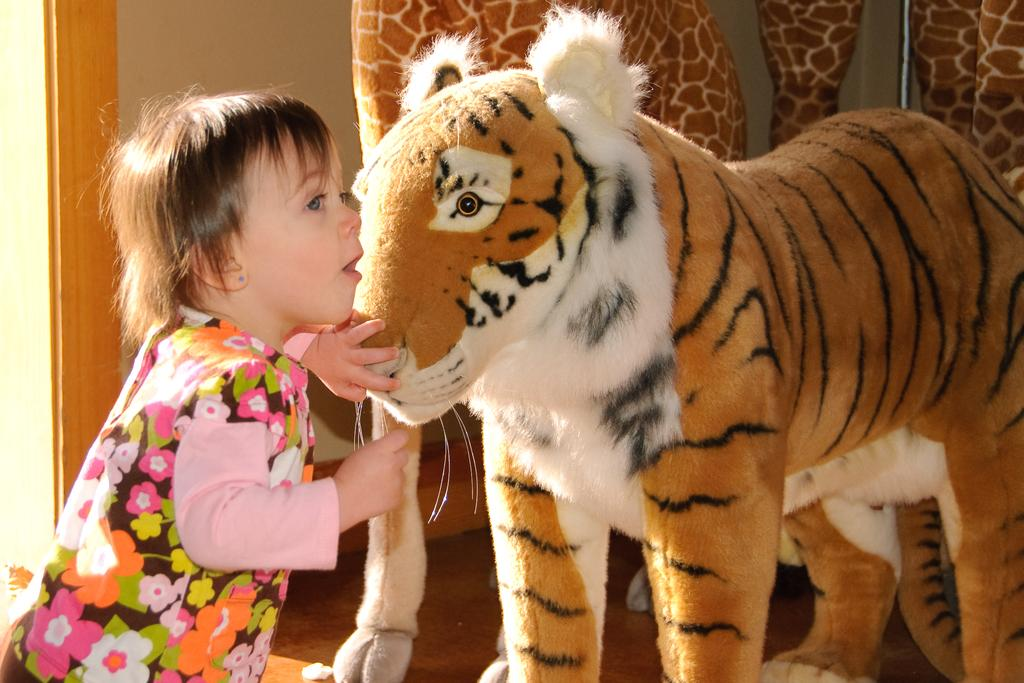What is the main subject of the image? The main subject of the image is a kid. What is the kid doing in the image? The kid is touching a tiger in the image. What type of tiger is the kid touching? The kid is touching a tiger that appears to be made of a soft material, like a stuffed animal or a plush toy. What is the kid wearing in the image? The kid is wearing a t-shirt in the image. What type of juice is the kid drinking in the image? There is no juice present in the image; the kid is touching a tiger. What type of air conditioning system is visible in the image? There is no air conditioning system visible in the image; the focus is on the kid and the tiger. 